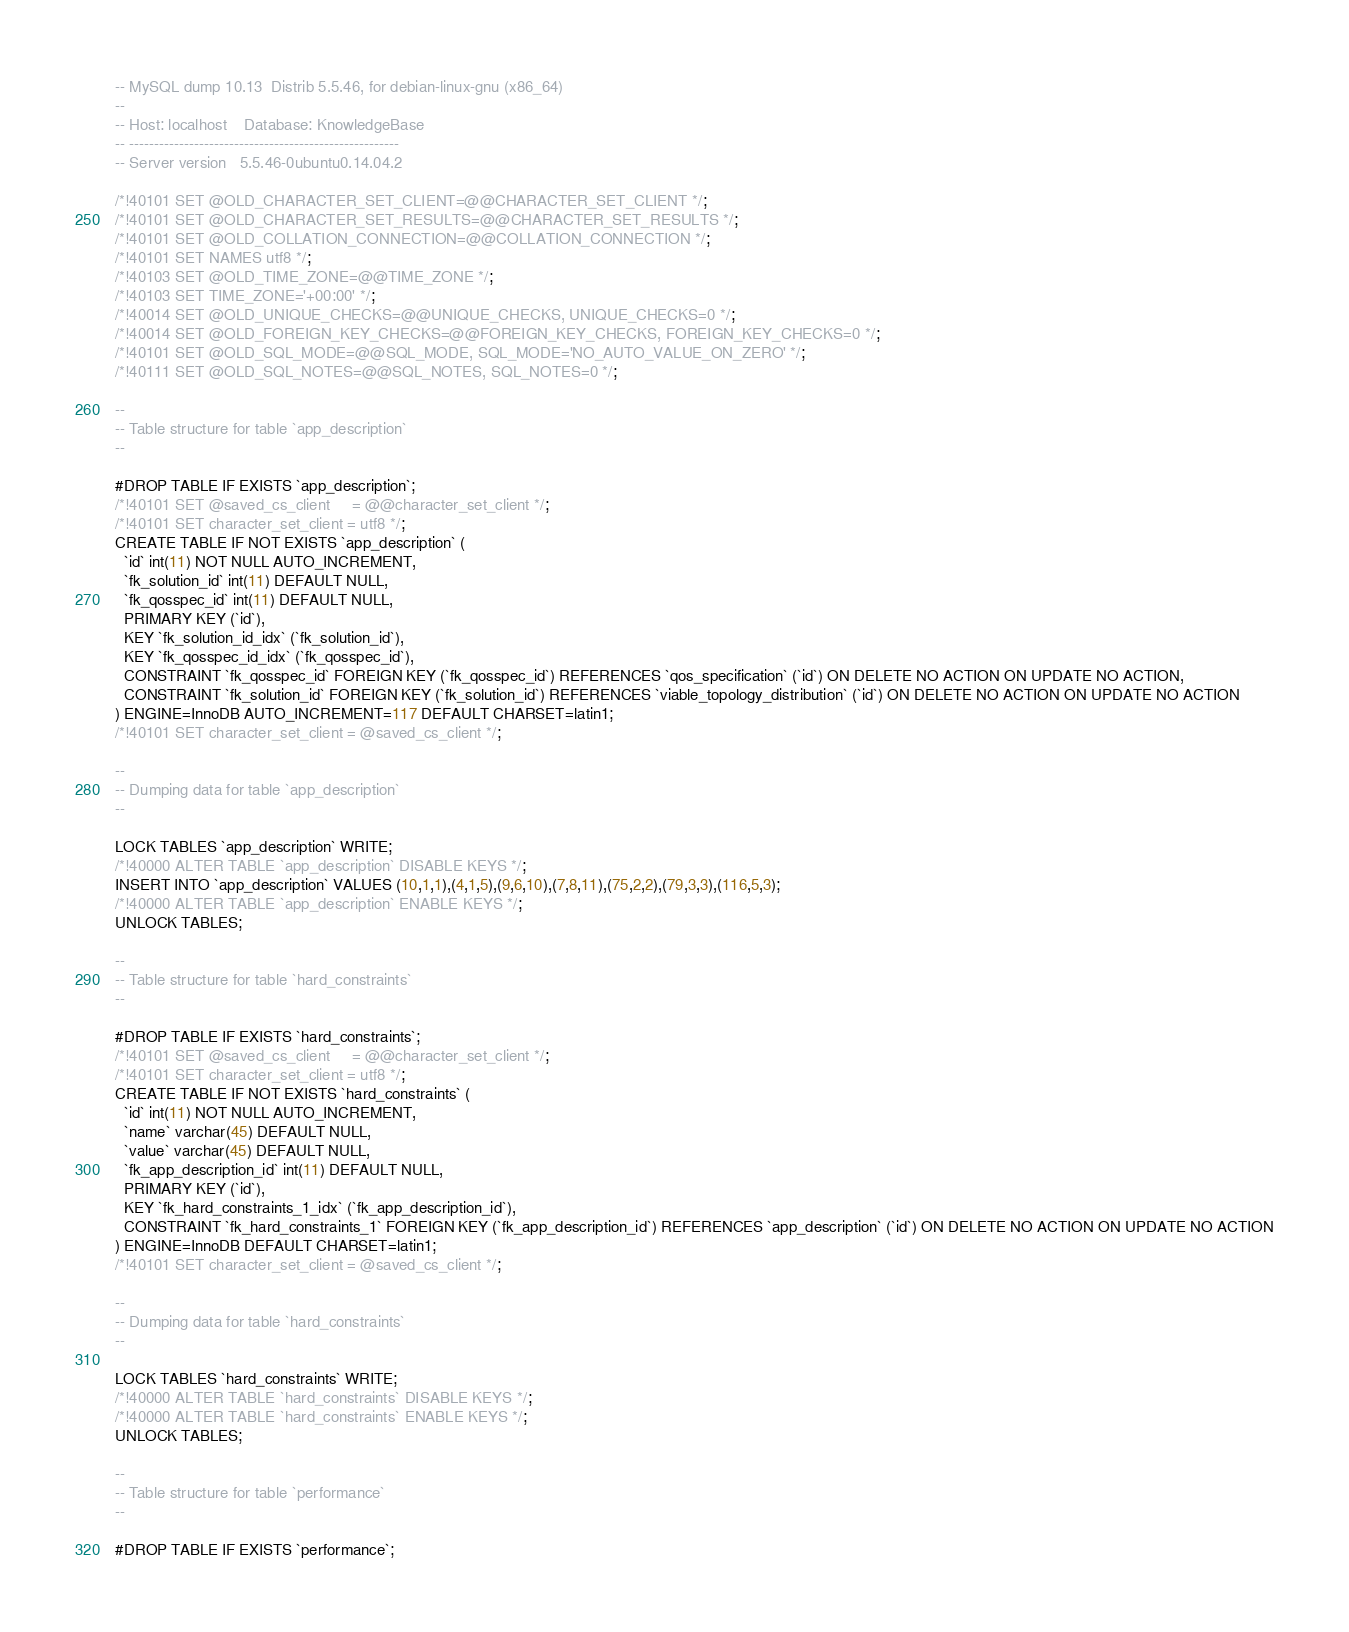<code> <loc_0><loc_0><loc_500><loc_500><_SQL_>-- MySQL dump 10.13  Distrib 5.5.46, for debian-linux-gnu (x86_64)
--
-- Host: localhost    Database: KnowledgeBase
-- ------------------------------------------------------
-- Server version	5.5.46-0ubuntu0.14.04.2

/*!40101 SET @OLD_CHARACTER_SET_CLIENT=@@CHARACTER_SET_CLIENT */;
/*!40101 SET @OLD_CHARACTER_SET_RESULTS=@@CHARACTER_SET_RESULTS */;
/*!40101 SET @OLD_COLLATION_CONNECTION=@@COLLATION_CONNECTION */;
/*!40101 SET NAMES utf8 */;
/*!40103 SET @OLD_TIME_ZONE=@@TIME_ZONE */;
/*!40103 SET TIME_ZONE='+00:00' */;
/*!40014 SET @OLD_UNIQUE_CHECKS=@@UNIQUE_CHECKS, UNIQUE_CHECKS=0 */;
/*!40014 SET @OLD_FOREIGN_KEY_CHECKS=@@FOREIGN_KEY_CHECKS, FOREIGN_KEY_CHECKS=0 */;
/*!40101 SET @OLD_SQL_MODE=@@SQL_MODE, SQL_MODE='NO_AUTO_VALUE_ON_ZERO' */;
/*!40111 SET @OLD_SQL_NOTES=@@SQL_NOTES, SQL_NOTES=0 */;

--
-- Table structure for table `app_description`
--

#DROP TABLE IF EXISTS `app_description`;
/*!40101 SET @saved_cs_client     = @@character_set_client */;
/*!40101 SET character_set_client = utf8 */;
CREATE TABLE IF NOT EXISTS `app_description` (
  `id` int(11) NOT NULL AUTO_INCREMENT,
  `fk_solution_id` int(11) DEFAULT NULL,
  `fk_qosspec_id` int(11) DEFAULT NULL,
  PRIMARY KEY (`id`),
  KEY `fk_solution_id_idx` (`fk_solution_id`),
  KEY `fk_qosspec_id_idx` (`fk_qosspec_id`),
  CONSTRAINT `fk_qosspec_id` FOREIGN KEY (`fk_qosspec_id`) REFERENCES `qos_specification` (`id`) ON DELETE NO ACTION ON UPDATE NO ACTION,
  CONSTRAINT `fk_solution_id` FOREIGN KEY (`fk_solution_id`) REFERENCES `viable_topology_distribution` (`id`) ON DELETE NO ACTION ON UPDATE NO ACTION
) ENGINE=InnoDB AUTO_INCREMENT=117 DEFAULT CHARSET=latin1;
/*!40101 SET character_set_client = @saved_cs_client */;

--
-- Dumping data for table `app_description`
--

LOCK TABLES `app_description` WRITE;
/*!40000 ALTER TABLE `app_description` DISABLE KEYS */;
INSERT INTO `app_description` VALUES (10,1,1),(4,1,5),(9,6,10),(7,8,11),(75,2,2),(79,3,3),(116,5,3);
/*!40000 ALTER TABLE `app_description` ENABLE KEYS */;
UNLOCK TABLES;

--
-- Table structure for table `hard_constraints`
--

#DROP TABLE IF EXISTS `hard_constraints`;
/*!40101 SET @saved_cs_client     = @@character_set_client */;
/*!40101 SET character_set_client = utf8 */;
CREATE TABLE IF NOT EXISTS `hard_constraints` (
  `id` int(11) NOT NULL AUTO_INCREMENT,
  `name` varchar(45) DEFAULT NULL,
  `value` varchar(45) DEFAULT NULL,
  `fk_app_description_id` int(11) DEFAULT NULL,
  PRIMARY KEY (`id`),
  KEY `fk_hard_constraints_1_idx` (`fk_app_description_id`),
  CONSTRAINT `fk_hard_constraints_1` FOREIGN KEY (`fk_app_description_id`) REFERENCES `app_description` (`id`) ON DELETE NO ACTION ON UPDATE NO ACTION
) ENGINE=InnoDB DEFAULT CHARSET=latin1;
/*!40101 SET character_set_client = @saved_cs_client */;

--
-- Dumping data for table `hard_constraints`
--

LOCK TABLES `hard_constraints` WRITE;
/*!40000 ALTER TABLE `hard_constraints` DISABLE KEYS */;
/*!40000 ALTER TABLE `hard_constraints` ENABLE KEYS */;
UNLOCK TABLES;

--
-- Table structure for table `performance`
--

#DROP TABLE IF EXISTS `performance`;</code> 